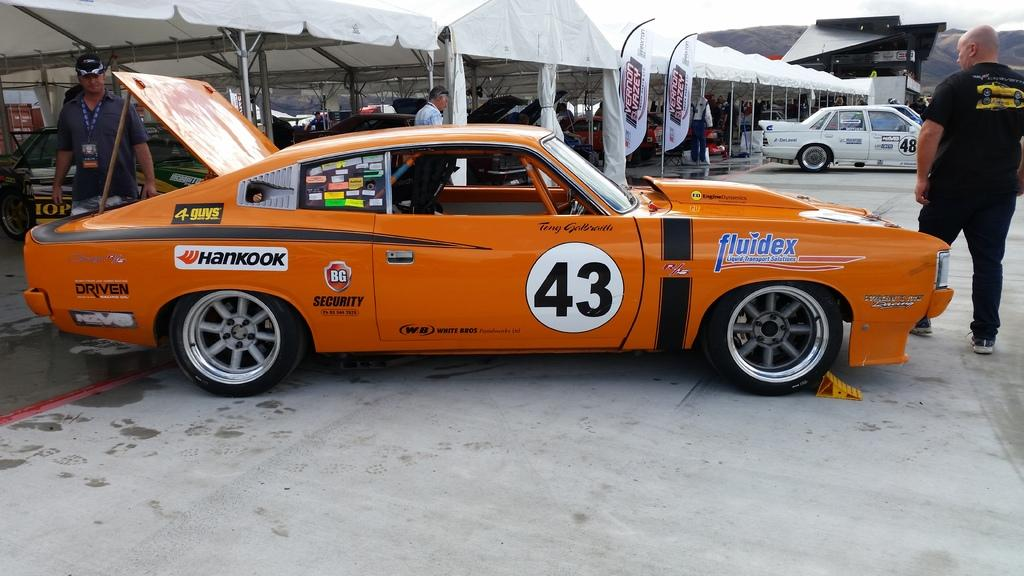What is the main subject of the image? The main subject of the image is a car. Are there any people present in the image? Yes, there are people in the image. What can be seen in the background of the image? There are other cars in the background of the image. What type of temporary structures are present in the image? There are tents with poles in the image. What additional decorative elements can be seen in the image? There are banners in the image. What type of wax is being used to grip the car's tires in the image? There is no wax or any mention of tire grip in the image; it simply shows a car and other related elements. 